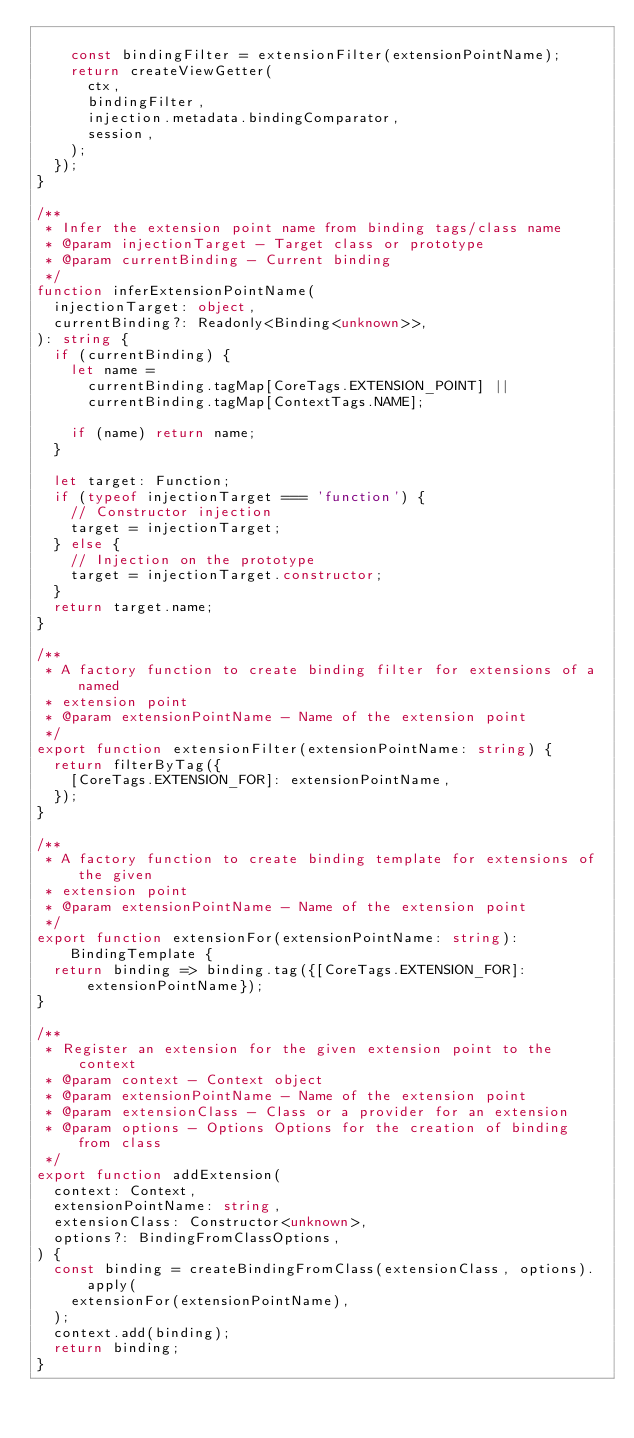Convert code to text. <code><loc_0><loc_0><loc_500><loc_500><_TypeScript_>
    const bindingFilter = extensionFilter(extensionPointName);
    return createViewGetter(
      ctx,
      bindingFilter,
      injection.metadata.bindingComparator,
      session,
    );
  });
}

/**
 * Infer the extension point name from binding tags/class name
 * @param injectionTarget - Target class or prototype
 * @param currentBinding - Current binding
 */
function inferExtensionPointName(
  injectionTarget: object,
  currentBinding?: Readonly<Binding<unknown>>,
): string {
  if (currentBinding) {
    let name =
      currentBinding.tagMap[CoreTags.EXTENSION_POINT] ||
      currentBinding.tagMap[ContextTags.NAME];

    if (name) return name;
  }

  let target: Function;
  if (typeof injectionTarget === 'function') {
    // Constructor injection
    target = injectionTarget;
  } else {
    // Injection on the prototype
    target = injectionTarget.constructor;
  }
  return target.name;
}

/**
 * A factory function to create binding filter for extensions of a named
 * extension point
 * @param extensionPointName - Name of the extension point
 */
export function extensionFilter(extensionPointName: string) {
  return filterByTag({
    [CoreTags.EXTENSION_FOR]: extensionPointName,
  });
}

/**
 * A factory function to create binding template for extensions of the given
 * extension point
 * @param extensionPointName - Name of the extension point
 */
export function extensionFor(extensionPointName: string): BindingTemplate {
  return binding => binding.tag({[CoreTags.EXTENSION_FOR]: extensionPointName});
}

/**
 * Register an extension for the given extension point to the context
 * @param context - Context object
 * @param extensionPointName - Name of the extension point
 * @param extensionClass - Class or a provider for an extension
 * @param options - Options Options for the creation of binding from class
 */
export function addExtension(
  context: Context,
  extensionPointName: string,
  extensionClass: Constructor<unknown>,
  options?: BindingFromClassOptions,
) {
  const binding = createBindingFromClass(extensionClass, options).apply(
    extensionFor(extensionPointName),
  );
  context.add(binding);
  return binding;
}
</code> 